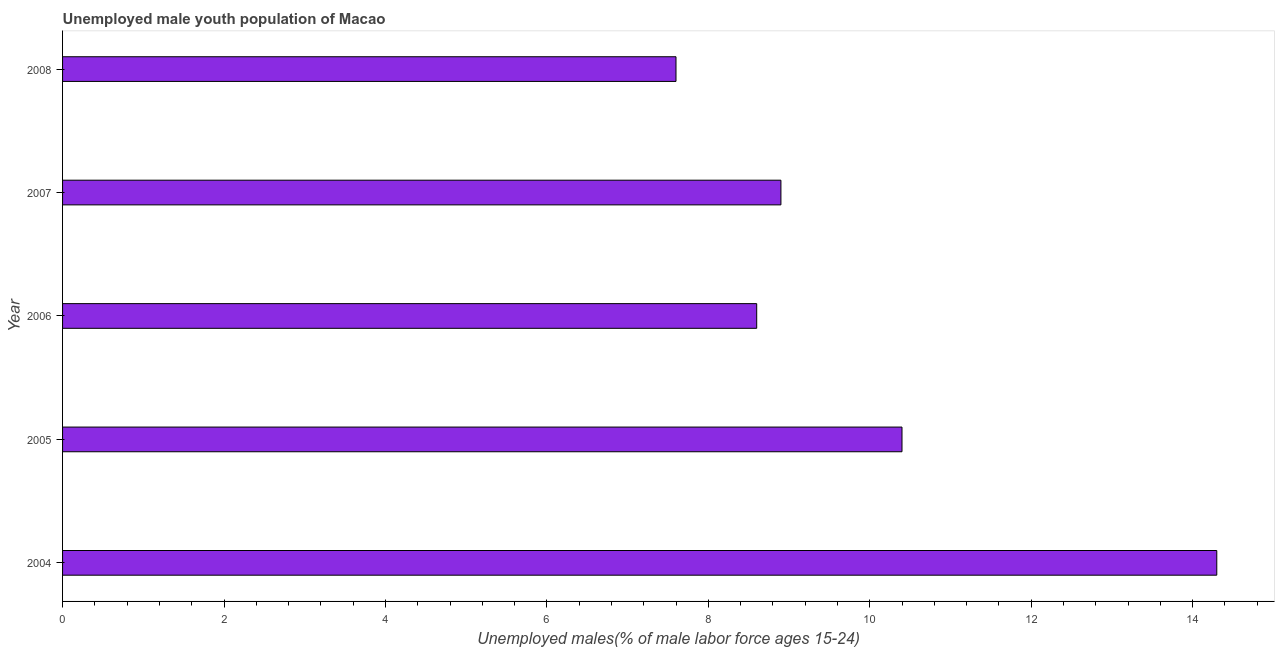What is the title of the graph?
Make the answer very short. Unemployed male youth population of Macao. What is the label or title of the X-axis?
Make the answer very short. Unemployed males(% of male labor force ages 15-24). What is the unemployed male youth in 2005?
Your response must be concise. 10.4. Across all years, what is the maximum unemployed male youth?
Your answer should be very brief. 14.3. Across all years, what is the minimum unemployed male youth?
Offer a terse response. 7.6. In which year was the unemployed male youth minimum?
Offer a very short reply. 2008. What is the sum of the unemployed male youth?
Ensure brevity in your answer.  49.8. What is the average unemployed male youth per year?
Make the answer very short. 9.96. What is the median unemployed male youth?
Your answer should be compact. 8.9. What is the ratio of the unemployed male youth in 2004 to that in 2008?
Your answer should be compact. 1.88. Is the unemployed male youth in 2005 less than that in 2008?
Your response must be concise. No. Is the difference between the unemployed male youth in 2006 and 2008 greater than the difference between any two years?
Your response must be concise. No. In how many years, is the unemployed male youth greater than the average unemployed male youth taken over all years?
Offer a very short reply. 2. How many bars are there?
Give a very brief answer. 5. Are all the bars in the graph horizontal?
Your answer should be very brief. Yes. How many years are there in the graph?
Make the answer very short. 5. What is the Unemployed males(% of male labor force ages 15-24) of 2004?
Keep it short and to the point. 14.3. What is the Unemployed males(% of male labor force ages 15-24) of 2005?
Your response must be concise. 10.4. What is the Unemployed males(% of male labor force ages 15-24) of 2006?
Give a very brief answer. 8.6. What is the Unemployed males(% of male labor force ages 15-24) of 2007?
Give a very brief answer. 8.9. What is the Unemployed males(% of male labor force ages 15-24) of 2008?
Offer a terse response. 7.6. What is the difference between the Unemployed males(% of male labor force ages 15-24) in 2004 and 2008?
Your answer should be very brief. 6.7. What is the difference between the Unemployed males(% of male labor force ages 15-24) in 2006 and 2008?
Give a very brief answer. 1. What is the ratio of the Unemployed males(% of male labor force ages 15-24) in 2004 to that in 2005?
Offer a very short reply. 1.38. What is the ratio of the Unemployed males(% of male labor force ages 15-24) in 2004 to that in 2006?
Offer a very short reply. 1.66. What is the ratio of the Unemployed males(% of male labor force ages 15-24) in 2004 to that in 2007?
Your answer should be compact. 1.61. What is the ratio of the Unemployed males(% of male labor force ages 15-24) in 2004 to that in 2008?
Your answer should be very brief. 1.88. What is the ratio of the Unemployed males(% of male labor force ages 15-24) in 2005 to that in 2006?
Provide a short and direct response. 1.21. What is the ratio of the Unemployed males(% of male labor force ages 15-24) in 2005 to that in 2007?
Your answer should be very brief. 1.17. What is the ratio of the Unemployed males(% of male labor force ages 15-24) in 2005 to that in 2008?
Your answer should be very brief. 1.37. What is the ratio of the Unemployed males(% of male labor force ages 15-24) in 2006 to that in 2008?
Offer a very short reply. 1.13. What is the ratio of the Unemployed males(% of male labor force ages 15-24) in 2007 to that in 2008?
Ensure brevity in your answer.  1.17. 